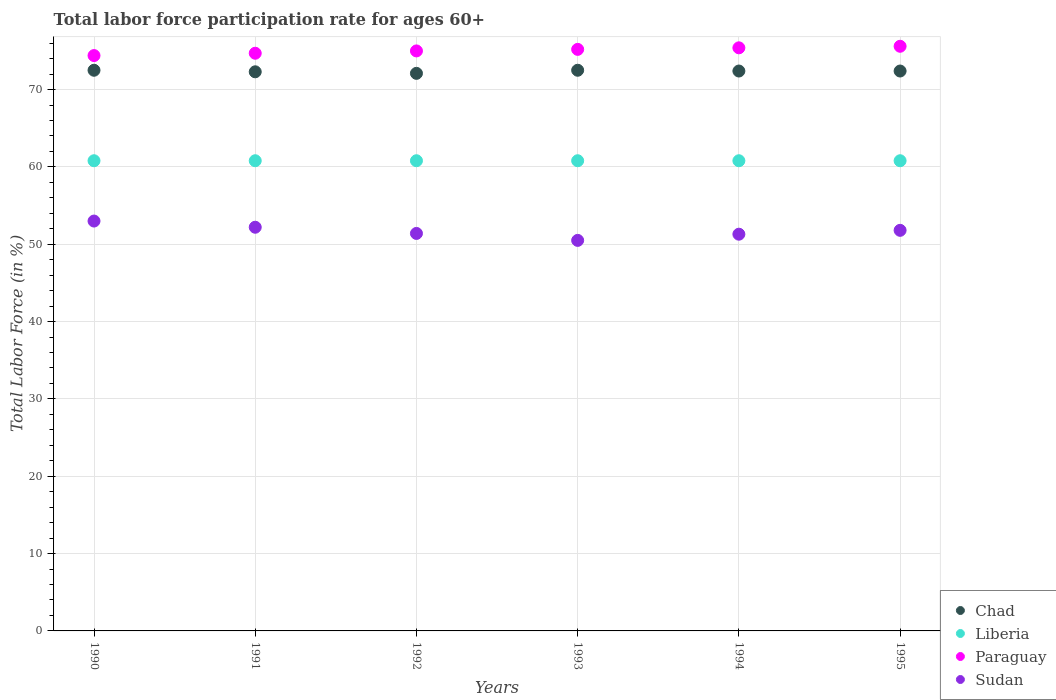What is the labor force participation rate in Paraguay in 1991?
Give a very brief answer. 74.7. Across all years, what is the maximum labor force participation rate in Paraguay?
Make the answer very short. 75.6. Across all years, what is the minimum labor force participation rate in Sudan?
Give a very brief answer. 50.5. What is the total labor force participation rate in Chad in the graph?
Keep it short and to the point. 434.2. What is the difference between the labor force participation rate in Paraguay in 1990 and that in 1994?
Your answer should be very brief. -1. What is the difference between the labor force participation rate in Sudan in 1994 and the labor force participation rate in Chad in 1992?
Offer a very short reply. -20.8. What is the average labor force participation rate in Liberia per year?
Offer a very short reply. 60.8. In the year 1991, what is the difference between the labor force participation rate in Sudan and labor force participation rate in Chad?
Your answer should be compact. -20.1. What is the ratio of the labor force participation rate in Chad in 1993 to that in 1995?
Offer a terse response. 1. What is the difference between the highest and the lowest labor force participation rate in Paraguay?
Your answer should be very brief. 1.2. In how many years, is the labor force participation rate in Liberia greater than the average labor force participation rate in Liberia taken over all years?
Make the answer very short. 0. Is the sum of the labor force participation rate in Sudan in 1990 and 1993 greater than the maximum labor force participation rate in Paraguay across all years?
Your answer should be compact. Yes. Is it the case that in every year, the sum of the labor force participation rate in Paraguay and labor force participation rate in Liberia  is greater than the sum of labor force participation rate in Chad and labor force participation rate in Sudan?
Keep it short and to the point. No. Is it the case that in every year, the sum of the labor force participation rate in Paraguay and labor force participation rate in Chad  is greater than the labor force participation rate in Liberia?
Make the answer very short. Yes. Is the labor force participation rate in Sudan strictly greater than the labor force participation rate in Chad over the years?
Provide a short and direct response. No. Is the labor force participation rate in Sudan strictly less than the labor force participation rate in Liberia over the years?
Provide a succinct answer. Yes. How many dotlines are there?
Offer a terse response. 4. How many years are there in the graph?
Your answer should be compact. 6. What is the difference between two consecutive major ticks on the Y-axis?
Offer a terse response. 10. Are the values on the major ticks of Y-axis written in scientific E-notation?
Offer a terse response. No. How many legend labels are there?
Give a very brief answer. 4. How are the legend labels stacked?
Keep it short and to the point. Vertical. What is the title of the graph?
Make the answer very short. Total labor force participation rate for ages 60+. Does "Other small states" appear as one of the legend labels in the graph?
Offer a very short reply. No. What is the label or title of the X-axis?
Give a very brief answer. Years. What is the Total Labor Force (in %) in Chad in 1990?
Provide a short and direct response. 72.5. What is the Total Labor Force (in %) in Liberia in 1990?
Offer a terse response. 60.8. What is the Total Labor Force (in %) in Paraguay in 1990?
Give a very brief answer. 74.4. What is the Total Labor Force (in %) of Sudan in 1990?
Keep it short and to the point. 53. What is the Total Labor Force (in %) of Chad in 1991?
Provide a short and direct response. 72.3. What is the Total Labor Force (in %) of Liberia in 1991?
Provide a succinct answer. 60.8. What is the Total Labor Force (in %) of Paraguay in 1991?
Offer a terse response. 74.7. What is the Total Labor Force (in %) of Sudan in 1991?
Provide a short and direct response. 52.2. What is the Total Labor Force (in %) in Chad in 1992?
Keep it short and to the point. 72.1. What is the Total Labor Force (in %) in Liberia in 1992?
Offer a terse response. 60.8. What is the Total Labor Force (in %) of Paraguay in 1992?
Offer a very short reply. 75. What is the Total Labor Force (in %) of Sudan in 1992?
Make the answer very short. 51.4. What is the Total Labor Force (in %) in Chad in 1993?
Your answer should be very brief. 72.5. What is the Total Labor Force (in %) in Liberia in 1993?
Give a very brief answer. 60.8. What is the Total Labor Force (in %) of Paraguay in 1993?
Your answer should be compact. 75.2. What is the Total Labor Force (in %) of Sudan in 1993?
Your answer should be compact. 50.5. What is the Total Labor Force (in %) in Chad in 1994?
Offer a very short reply. 72.4. What is the Total Labor Force (in %) in Liberia in 1994?
Your response must be concise. 60.8. What is the Total Labor Force (in %) of Paraguay in 1994?
Provide a short and direct response. 75.4. What is the Total Labor Force (in %) in Sudan in 1994?
Make the answer very short. 51.3. What is the Total Labor Force (in %) in Chad in 1995?
Offer a very short reply. 72.4. What is the Total Labor Force (in %) in Liberia in 1995?
Your answer should be compact. 60.8. What is the Total Labor Force (in %) of Paraguay in 1995?
Make the answer very short. 75.6. What is the Total Labor Force (in %) of Sudan in 1995?
Your answer should be very brief. 51.8. Across all years, what is the maximum Total Labor Force (in %) in Chad?
Your response must be concise. 72.5. Across all years, what is the maximum Total Labor Force (in %) in Liberia?
Keep it short and to the point. 60.8. Across all years, what is the maximum Total Labor Force (in %) in Paraguay?
Make the answer very short. 75.6. Across all years, what is the maximum Total Labor Force (in %) of Sudan?
Ensure brevity in your answer.  53. Across all years, what is the minimum Total Labor Force (in %) in Chad?
Provide a short and direct response. 72.1. Across all years, what is the minimum Total Labor Force (in %) in Liberia?
Ensure brevity in your answer.  60.8. Across all years, what is the minimum Total Labor Force (in %) of Paraguay?
Provide a succinct answer. 74.4. Across all years, what is the minimum Total Labor Force (in %) in Sudan?
Give a very brief answer. 50.5. What is the total Total Labor Force (in %) in Chad in the graph?
Your answer should be very brief. 434.2. What is the total Total Labor Force (in %) of Liberia in the graph?
Ensure brevity in your answer.  364.8. What is the total Total Labor Force (in %) of Paraguay in the graph?
Provide a succinct answer. 450.3. What is the total Total Labor Force (in %) in Sudan in the graph?
Make the answer very short. 310.2. What is the difference between the Total Labor Force (in %) in Paraguay in 1990 and that in 1991?
Your answer should be very brief. -0.3. What is the difference between the Total Labor Force (in %) of Chad in 1990 and that in 1992?
Your answer should be very brief. 0.4. What is the difference between the Total Labor Force (in %) in Liberia in 1990 and that in 1992?
Your response must be concise. 0. What is the difference between the Total Labor Force (in %) in Sudan in 1990 and that in 1992?
Offer a terse response. 1.6. What is the difference between the Total Labor Force (in %) in Chad in 1990 and that in 1993?
Offer a very short reply. 0. What is the difference between the Total Labor Force (in %) in Liberia in 1990 and that in 1993?
Provide a succinct answer. 0. What is the difference between the Total Labor Force (in %) of Chad in 1990 and that in 1994?
Give a very brief answer. 0.1. What is the difference between the Total Labor Force (in %) of Liberia in 1990 and that in 1994?
Offer a terse response. 0. What is the difference between the Total Labor Force (in %) of Paraguay in 1990 and that in 1994?
Offer a terse response. -1. What is the difference between the Total Labor Force (in %) of Liberia in 1990 and that in 1995?
Offer a terse response. 0. What is the difference between the Total Labor Force (in %) in Paraguay in 1990 and that in 1995?
Offer a very short reply. -1.2. What is the difference between the Total Labor Force (in %) of Liberia in 1991 and that in 1992?
Your response must be concise. 0. What is the difference between the Total Labor Force (in %) of Sudan in 1991 and that in 1992?
Offer a very short reply. 0.8. What is the difference between the Total Labor Force (in %) in Chad in 1991 and that in 1994?
Make the answer very short. -0.1. What is the difference between the Total Labor Force (in %) of Liberia in 1991 and that in 1994?
Provide a short and direct response. 0. What is the difference between the Total Labor Force (in %) in Sudan in 1991 and that in 1994?
Offer a terse response. 0.9. What is the difference between the Total Labor Force (in %) in Chad in 1991 and that in 1995?
Ensure brevity in your answer.  -0.1. What is the difference between the Total Labor Force (in %) of Paraguay in 1991 and that in 1995?
Provide a short and direct response. -0.9. What is the difference between the Total Labor Force (in %) of Sudan in 1991 and that in 1995?
Offer a terse response. 0.4. What is the difference between the Total Labor Force (in %) of Paraguay in 1992 and that in 1993?
Offer a terse response. -0.2. What is the difference between the Total Labor Force (in %) of Sudan in 1992 and that in 1993?
Ensure brevity in your answer.  0.9. What is the difference between the Total Labor Force (in %) in Liberia in 1992 and that in 1994?
Ensure brevity in your answer.  0. What is the difference between the Total Labor Force (in %) of Chad in 1992 and that in 1995?
Offer a terse response. -0.3. What is the difference between the Total Labor Force (in %) in Paraguay in 1992 and that in 1995?
Your answer should be compact. -0.6. What is the difference between the Total Labor Force (in %) of Chad in 1993 and that in 1994?
Provide a succinct answer. 0.1. What is the difference between the Total Labor Force (in %) of Liberia in 1993 and that in 1994?
Offer a very short reply. 0. What is the difference between the Total Labor Force (in %) of Paraguay in 1993 and that in 1994?
Give a very brief answer. -0.2. What is the difference between the Total Labor Force (in %) of Liberia in 1993 and that in 1995?
Ensure brevity in your answer.  0. What is the difference between the Total Labor Force (in %) in Chad in 1994 and that in 1995?
Make the answer very short. 0. What is the difference between the Total Labor Force (in %) of Liberia in 1994 and that in 1995?
Keep it short and to the point. 0. What is the difference between the Total Labor Force (in %) of Paraguay in 1994 and that in 1995?
Make the answer very short. -0.2. What is the difference between the Total Labor Force (in %) in Sudan in 1994 and that in 1995?
Your answer should be very brief. -0.5. What is the difference between the Total Labor Force (in %) in Chad in 1990 and the Total Labor Force (in %) in Liberia in 1991?
Provide a short and direct response. 11.7. What is the difference between the Total Labor Force (in %) in Chad in 1990 and the Total Labor Force (in %) in Paraguay in 1991?
Ensure brevity in your answer.  -2.2. What is the difference between the Total Labor Force (in %) of Chad in 1990 and the Total Labor Force (in %) of Sudan in 1991?
Make the answer very short. 20.3. What is the difference between the Total Labor Force (in %) of Chad in 1990 and the Total Labor Force (in %) of Sudan in 1992?
Give a very brief answer. 21.1. What is the difference between the Total Labor Force (in %) in Liberia in 1990 and the Total Labor Force (in %) in Paraguay in 1993?
Your answer should be very brief. -14.4. What is the difference between the Total Labor Force (in %) of Paraguay in 1990 and the Total Labor Force (in %) of Sudan in 1993?
Ensure brevity in your answer.  23.9. What is the difference between the Total Labor Force (in %) in Chad in 1990 and the Total Labor Force (in %) in Liberia in 1994?
Your response must be concise. 11.7. What is the difference between the Total Labor Force (in %) of Chad in 1990 and the Total Labor Force (in %) of Paraguay in 1994?
Make the answer very short. -2.9. What is the difference between the Total Labor Force (in %) of Chad in 1990 and the Total Labor Force (in %) of Sudan in 1994?
Your answer should be compact. 21.2. What is the difference between the Total Labor Force (in %) in Liberia in 1990 and the Total Labor Force (in %) in Paraguay in 1994?
Your answer should be compact. -14.6. What is the difference between the Total Labor Force (in %) of Paraguay in 1990 and the Total Labor Force (in %) of Sudan in 1994?
Your answer should be compact. 23.1. What is the difference between the Total Labor Force (in %) of Chad in 1990 and the Total Labor Force (in %) of Paraguay in 1995?
Your answer should be compact. -3.1. What is the difference between the Total Labor Force (in %) of Chad in 1990 and the Total Labor Force (in %) of Sudan in 1995?
Offer a terse response. 20.7. What is the difference between the Total Labor Force (in %) of Liberia in 1990 and the Total Labor Force (in %) of Paraguay in 1995?
Your response must be concise. -14.8. What is the difference between the Total Labor Force (in %) of Paraguay in 1990 and the Total Labor Force (in %) of Sudan in 1995?
Your response must be concise. 22.6. What is the difference between the Total Labor Force (in %) in Chad in 1991 and the Total Labor Force (in %) in Liberia in 1992?
Offer a very short reply. 11.5. What is the difference between the Total Labor Force (in %) in Chad in 1991 and the Total Labor Force (in %) in Sudan in 1992?
Give a very brief answer. 20.9. What is the difference between the Total Labor Force (in %) in Liberia in 1991 and the Total Labor Force (in %) in Sudan in 1992?
Provide a short and direct response. 9.4. What is the difference between the Total Labor Force (in %) in Paraguay in 1991 and the Total Labor Force (in %) in Sudan in 1992?
Your answer should be compact. 23.3. What is the difference between the Total Labor Force (in %) of Chad in 1991 and the Total Labor Force (in %) of Liberia in 1993?
Your answer should be very brief. 11.5. What is the difference between the Total Labor Force (in %) in Chad in 1991 and the Total Labor Force (in %) in Sudan in 1993?
Ensure brevity in your answer.  21.8. What is the difference between the Total Labor Force (in %) in Liberia in 1991 and the Total Labor Force (in %) in Paraguay in 1993?
Offer a terse response. -14.4. What is the difference between the Total Labor Force (in %) in Paraguay in 1991 and the Total Labor Force (in %) in Sudan in 1993?
Give a very brief answer. 24.2. What is the difference between the Total Labor Force (in %) of Chad in 1991 and the Total Labor Force (in %) of Liberia in 1994?
Ensure brevity in your answer.  11.5. What is the difference between the Total Labor Force (in %) in Chad in 1991 and the Total Labor Force (in %) in Sudan in 1994?
Your response must be concise. 21. What is the difference between the Total Labor Force (in %) in Liberia in 1991 and the Total Labor Force (in %) in Paraguay in 1994?
Ensure brevity in your answer.  -14.6. What is the difference between the Total Labor Force (in %) of Paraguay in 1991 and the Total Labor Force (in %) of Sudan in 1994?
Offer a very short reply. 23.4. What is the difference between the Total Labor Force (in %) of Chad in 1991 and the Total Labor Force (in %) of Paraguay in 1995?
Offer a terse response. -3.3. What is the difference between the Total Labor Force (in %) in Chad in 1991 and the Total Labor Force (in %) in Sudan in 1995?
Your response must be concise. 20.5. What is the difference between the Total Labor Force (in %) in Liberia in 1991 and the Total Labor Force (in %) in Paraguay in 1995?
Make the answer very short. -14.8. What is the difference between the Total Labor Force (in %) in Paraguay in 1991 and the Total Labor Force (in %) in Sudan in 1995?
Ensure brevity in your answer.  22.9. What is the difference between the Total Labor Force (in %) of Chad in 1992 and the Total Labor Force (in %) of Paraguay in 1993?
Offer a terse response. -3.1. What is the difference between the Total Labor Force (in %) in Chad in 1992 and the Total Labor Force (in %) in Sudan in 1993?
Ensure brevity in your answer.  21.6. What is the difference between the Total Labor Force (in %) of Liberia in 1992 and the Total Labor Force (in %) of Paraguay in 1993?
Your answer should be compact. -14.4. What is the difference between the Total Labor Force (in %) in Chad in 1992 and the Total Labor Force (in %) in Liberia in 1994?
Provide a short and direct response. 11.3. What is the difference between the Total Labor Force (in %) of Chad in 1992 and the Total Labor Force (in %) of Sudan in 1994?
Provide a succinct answer. 20.8. What is the difference between the Total Labor Force (in %) in Liberia in 1992 and the Total Labor Force (in %) in Paraguay in 1994?
Offer a very short reply. -14.6. What is the difference between the Total Labor Force (in %) in Paraguay in 1992 and the Total Labor Force (in %) in Sudan in 1994?
Give a very brief answer. 23.7. What is the difference between the Total Labor Force (in %) in Chad in 1992 and the Total Labor Force (in %) in Liberia in 1995?
Give a very brief answer. 11.3. What is the difference between the Total Labor Force (in %) of Chad in 1992 and the Total Labor Force (in %) of Sudan in 1995?
Offer a terse response. 20.3. What is the difference between the Total Labor Force (in %) of Liberia in 1992 and the Total Labor Force (in %) of Paraguay in 1995?
Provide a short and direct response. -14.8. What is the difference between the Total Labor Force (in %) in Liberia in 1992 and the Total Labor Force (in %) in Sudan in 1995?
Offer a terse response. 9. What is the difference between the Total Labor Force (in %) in Paraguay in 1992 and the Total Labor Force (in %) in Sudan in 1995?
Your answer should be very brief. 23.2. What is the difference between the Total Labor Force (in %) in Chad in 1993 and the Total Labor Force (in %) in Sudan in 1994?
Your answer should be compact. 21.2. What is the difference between the Total Labor Force (in %) of Liberia in 1993 and the Total Labor Force (in %) of Paraguay in 1994?
Offer a terse response. -14.6. What is the difference between the Total Labor Force (in %) of Paraguay in 1993 and the Total Labor Force (in %) of Sudan in 1994?
Your answer should be compact. 23.9. What is the difference between the Total Labor Force (in %) in Chad in 1993 and the Total Labor Force (in %) in Liberia in 1995?
Offer a terse response. 11.7. What is the difference between the Total Labor Force (in %) in Chad in 1993 and the Total Labor Force (in %) in Paraguay in 1995?
Your answer should be very brief. -3.1. What is the difference between the Total Labor Force (in %) in Chad in 1993 and the Total Labor Force (in %) in Sudan in 1995?
Offer a very short reply. 20.7. What is the difference between the Total Labor Force (in %) of Liberia in 1993 and the Total Labor Force (in %) of Paraguay in 1995?
Ensure brevity in your answer.  -14.8. What is the difference between the Total Labor Force (in %) in Liberia in 1993 and the Total Labor Force (in %) in Sudan in 1995?
Make the answer very short. 9. What is the difference between the Total Labor Force (in %) in Paraguay in 1993 and the Total Labor Force (in %) in Sudan in 1995?
Your answer should be compact. 23.4. What is the difference between the Total Labor Force (in %) in Chad in 1994 and the Total Labor Force (in %) in Liberia in 1995?
Give a very brief answer. 11.6. What is the difference between the Total Labor Force (in %) in Chad in 1994 and the Total Labor Force (in %) in Sudan in 1995?
Your answer should be very brief. 20.6. What is the difference between the Total Labor Force (in %) in Liberia in 1994 and the Total Labor Force (in %) in Paraguay in 1995?
Your response must be concise. -14.8. What is the difference between the Total Labor Force (in %) in Liberia in 1994 and the Total Labor Force (in %) in Sudan in 1995?
Keep it short and to the point. 9. What is the difference between the Total Labor Force (in %) in Paraguay in 1994 and the Total Labor Force (in %) in Sudan in 1995?
Offer a very short reply. 23.6. What is the average Total Labor Force (in %) in Chad per year?
Offer a very short reply. 72.37. What is the average Total Labor Force (in %) of Liberia per year?
Ensure brevity in your answer.  60.8. What is the average Total Labor Force (in %) of Paraguay per year?
Keep it short and to the point. 75.05. What is the average Total Labor Force (in %) of Sudan per year?
Offer a very short reply. 51.7. In the year 1990, what is the difference between the Total Labor Force (in %) of Chad and Total Labor Force (in %) of Sudan?
Your response must be concise. 19.5. In the year 1990, what is the difference between the Total Labor Force (in %) of Liberia and Total Labor Force (in %) of Paraguay?
Keep it short and to the point. -13.6. In the year 1990, what is the difference between the Total Labor Force (in %) in Paraguay and Total Labor Force (in %) in Sudan?
Your answer should be very brief. 21.4. In the year 1991, what is the difference between the Total Labor Force (in %) in Chad and Total Labor Force (in %) in Liberia?
Provide a succinct answer. 11.5. In the year 1991, what is the difference between the Total Labor Force (in %) of Chad and Total Labor Force (in %) of Sudan?
Your answer should be very brief. 20.1. In the year 1991, what is the difference between the Total Labor Force (in %) of Liberia and Total Labor Force (in %) of Paraguay?
Your response must be concise. -13.9. In the year 1992, what is the difference between the Total Labor Force (in %) in Chad and Total Labor Force (in %) in Liberia?
Your response must be concise. 11.3. In the year 1992, what is the difference between the Total Labor Force (in %) in Chad and Total Labor Force (in %) in Paraguay?
Provide a short and direct response. -2.9. In the year 1992, what is the difference between the Total Labor Force (in %) in Chad and Total Labor Force (in %) in Sudan?
Make the answer very short. 20.7. In the year 1992, what is the difference between the Total Labor Force (in %) of Liberia and Total Labor Force (in %) of Paraguay?
Make the answer very short. -14.2. In the year 1992, what is the difference between the Total Labor Force (in %) of Liberia and Total Labor Force (in %) of Sudan?
Offer a very short reply. 9.4. In the year 1992, what is the difference between the Total Labor Force (in %) in Paraguay and Total Labor Force (in %) in Sudan?
Provide a short and direct response. 23.6. In the year 1993, what is the difference between the Total Labor Force (in %) of Chad and Total Labor Force (in %) of Paraguay?
Ensure brevity in your answer.  -2.7. In the year 1993, what is the difference between the Total Labor Force (in %) of Chad and Total Labor Force (in %) of Sudan?
Offer a terse response. 22. In the year 1993, what is the difference between the Total Labor Force (in %) in Liberia and Total Labor Force (in %) in Paraguay?
Give a very brief answer. -14.4. In the year 1993, what is the difference between the Total Labor Force (in %) in Paraguay and Total Labor Force (in %) in Sudan?
Offer a terse response. 24.7. In the year 1994, what is the difference between the Total Labor Force (in %) of Chad and Total Labor Force (in %) of Liberia?
Give a very brief answer. 11.6. In the year 1994, what is the difference between the Total Labor Force (in %) of Chad and Total Labor Force (in %) of Sudan?
Your answer should be compact. 21.1. In the year 1994, what is the difference between the Total Labor Force (in %) of Liberia and Total Labor Force (in %) of Paraguay?
Provide a succinct answer. -14.6. In the year 1994, what is the difference between the Total Labor Force (in %) in Liberia and Total Labor Force (in %) in Sudan?
Give a very brief answer. 9.5. In the year 1994, what is the difference between the Total Labor Force (in %) in Paraguay and Total Labor Force (in %) in Sudan?
Keep it short and to the point. 24.1. In the year 1995, what is the difference between the Total Labor Force (in %) in Chad and Total Labor Force (in %) in Liberia?
Your response must be concise. 11.6. In the year 1995, what is the difference between the Total Labor Force (in %) in Chad and Total Labor Force (in %) in Paraguay?
Ensure brevity in your answer.  -3.2. In the year 1995, what is the difference between the Total Labor Force (in %) in Chad and Total Labor Force (in %) in Sudan?
Offer a very short reply. 20.6. In the year 1995, what is the difference between the Total Labor Force (in %) of Liberia and Total Labor Force (in %) of Paraguay?
Your answer should be compact. -14.8. In the year 1995, what is the difference between the Total Labor Force (in %) in Liberia and Total Labor Force (in %) in Sudan?
Provide a succinct answer. 9. In the year 1995, what is the difference between the Total Labor Force (in %) of Paraguay and Total Labor Force (in %) of Sudan?
Provide a succinct answer. 23.8. What is the ratio of the Total Labor Force (in %) in Sudan in 1990 to that in 1991?
Offer a terse response. 1.02. What is the ratio of the Total Labor Force (in %) of Liberia in 1990 to that in 1992?
Give a very brief answer. 1. What is the ratio of the Total Labor Force (in %) in Paraguay in 1990 to that in 1992?
Provide a short and direct response. 0.99. What is the ratio of the Total Labor Force (in %) of Sudan in 1990 to that in 1992?
Keep it short and to the point. 1.03. What is the ratio of the Total Labor Force (in %) in Chad in 1990 to that in 1993?
Keep it short and to the point. 1. What is the ratio of the Total Labor Force (in %) of Sudan in 1990 to that in 1993?
Offer a very short reply. 1.05. What is the ratio of the Total Labor Force (in %) in Liberia in 1990 to that in 1994?
Keep it short and to the point. 1. What is the ratio of the Total Labor Force (in %) in Paraguay in 1990 to that in 1994?
Provide a succinct answer. 0.99. What is the ratio of the Total Labor Force (in %) of Sudan in 1990 to that in 1994?
Keep it short and to the point. 1.03. What is the ratio of the Total Labor Force (in %) in Liberia in 1990 to that in 1995?
Provide a succinct answer. 1. What is the ratio of the Total Labor Force (in %) of Paraguay in 1990 to that in 1995?
Your response must be concise. 0.98. What is the ratio of the Total Labor Force (in %) in Sudan in 1990 to that in 1995?
Your response must be concise. 1.02. What is the ratio of the Total Labor Force (in %) of Chad in 1991 to that in 1992?
Your response must be concise. 1. What is the ratio of the Total Labor Force (in %) in Liberia in 1991 to that in 1992?
Your answer should be compact. 1. What is the ratio of the Total Labor Force (in %) in Sudan in 1991 to that in 1992?
Your answer should be compact. 1.02. What is the ratio of the Total Labor Force (in %) of Chad in 1991 to that in 1993?
Provide a succinct answer. 1. What is the ratio of the Total Labor Force (in %) of Liberia in 1991 to that in 1993?
Keep it short and to the point. 1. What is the ratio of the Total Labor Force (in %) of Paraguay in 1991 to that in 1993?
Keep it short and to the point. 0.99. What is the ratio of the Total Labor Force (in %) in Sudan in 1991 to that in 1993?
Offer a very short reply. 1.03. What is the ratio of the Total Labor Force (in %) of Chad in 1991 to that in 1994?
Your answer should be compact. 1. What is the ratio of the Total Labor Force (in %) in Paraguay in 1991 to that in 1994?
Provide a succinct answer. 0.99. What is the ratio of the Total Labor Force (in %) of Sudan in 1991 to that in 1994?
Your response must be concise. 1.02. What is the ratio of the Total Labor Force (in %) in Sudan in 1991 to that in 1995?
Give a very brief answer. 1.01. What is the ratio of the Total Labor Force (in %) in Chad in 1992 to that in 1993?
Your response must be concise. 0.99. What is the ratio of the Total Labor Force (in %) of Sudan in 1992 to that in 1993?
Your response must be concise. 1.02. What is the ratio of the Total Labor Force (in %) of Paraguay in 1992 to that in 1994?
Offer a terse response. 0.99. What is the ratio of the Total Labor Force (in %) of Liberia in 1992 to that in 1995?
Your answer should be very brief. 1. What is the ratio of the Total Labor Force (in %) of Sudan in 1992 to that in 1995?
Offer a very short reply. 0.99. What is the ratio of the Total Labor Force (in %) in Chad in 1993 to that in 1994?
Your response must be concise. 1. What is the ratio of the Total Labor Force (in %) in Liberia in 1993 to that in 1994?
Your response must be concise. 1. What is the ratio of the Total Labor Force (in %) in Paraguay in 1993 to that in 1994?
Keep it short and to the point. 1. What is the ratio of the Total Labor Force (in %) in Sudan in 1993 to that in 1994?
Provide a short and direct response. 0.98. What is the ratio of the Total Labor Force (in %) of Paraguay in 1993 to that in 1995?
Offer a very short reply. 0.99. What is the ratio of the Total Labor Force (in %) in Sudan in 1993 to that in 1995?
Ensure brevity in your answer.  0.97. What is the ratio of the Total Labor Force (in %) in Sudan in 1994 to that in 1995?
Offer a terse response. 0.99. What is the difference between the highest and the second highest Total Labor Force (in %) in Liberia?
Provide a succinct answer. 0. What is the difference between the highest and the second highest Total Labor Force (in %) in Sudan?
Give a very brief answer. 0.8. What is the difference between the highest and the lowest Total Labor Force (in %) in Liberia?
Your answer should be very brief. 0. What is the difference between the highest and the lowest Total Labor Force (in %) of Paraguay?
Offer a terse response. 1.2. 